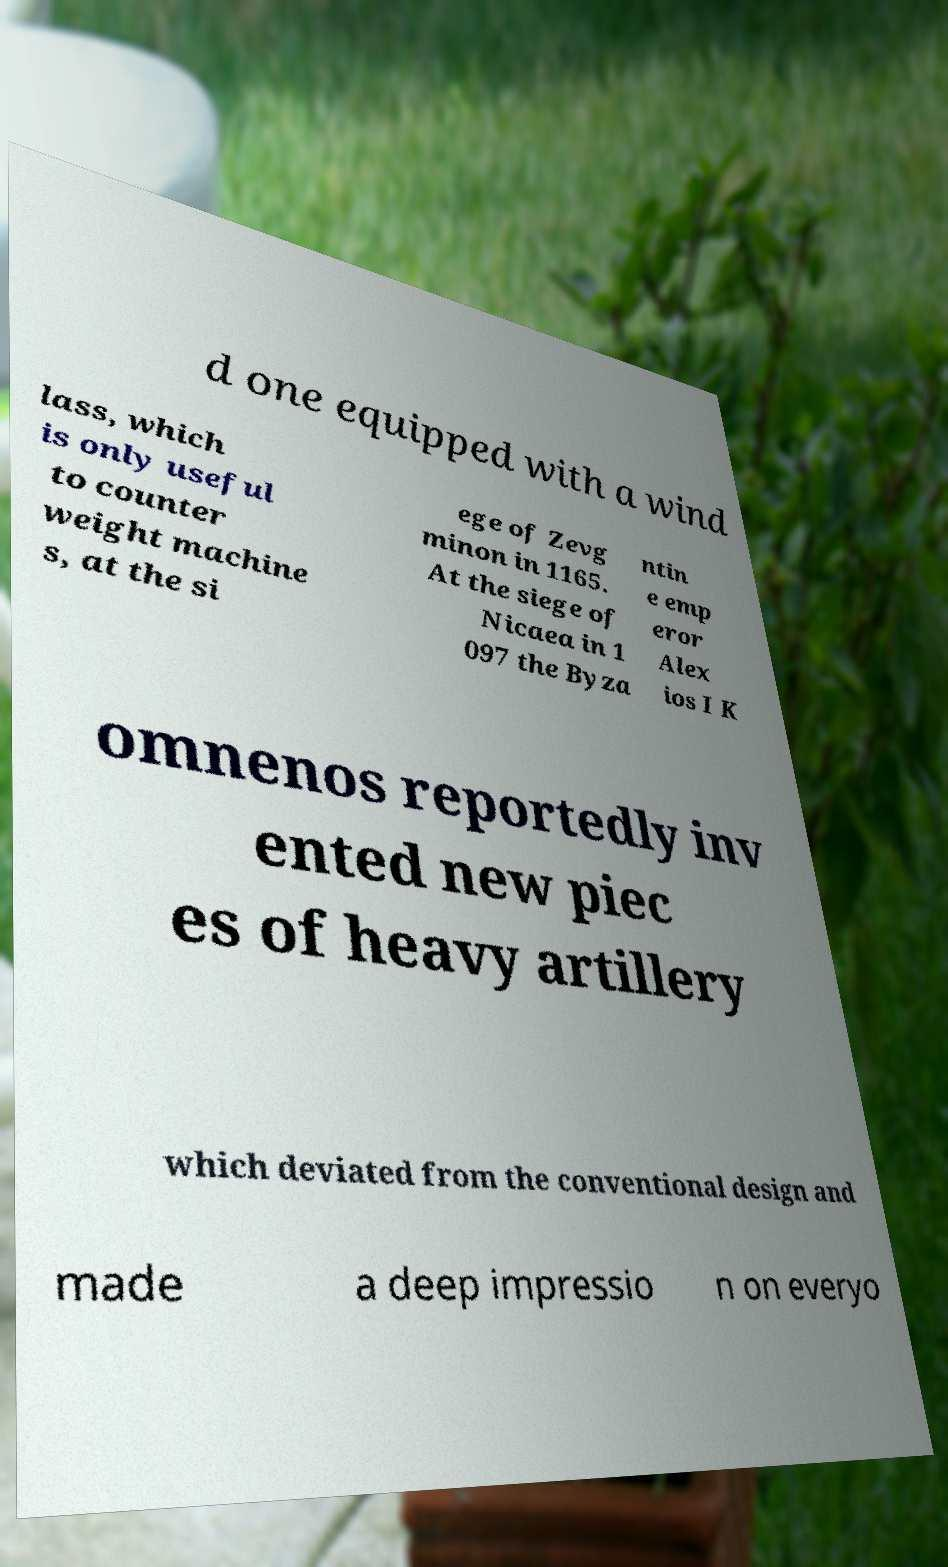For documentation purposes, I need the text within this image transcribed. Could you provide that? d one equipped with a wind lass, which is only useful to counter weight machine s, at the si ege of Zevg minon in 1165. At the siege of Nicaea in 1 097 the Byza ntin e emp eror Alex ios I K omnenos reportedly inv ented new piec es of heavy artillery which deviated from the conventional design and made a deep impressio n on everyo 